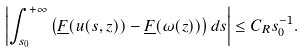Convert formula to latex. <formula><loc_0><loc_0><loc_500><loc_500>\left | \int _ { s _ { 0 } } ^ { + \infty } \left ( \underline { F } ( u ( s , z ) ) - \underline { F } ( \omega ( z ) ) \right ) d s \right | \leq C _ { R } s _ { 0 } ^ { - 1 } .</formula> 